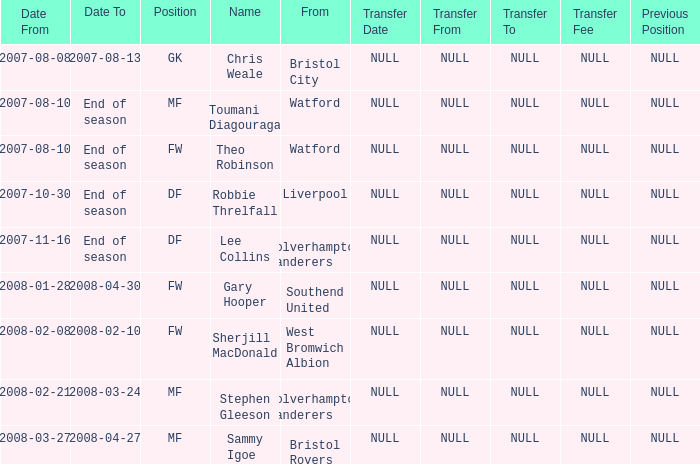For theo robinson, who was part of the team until the season finale, what was his date from? 2007-08-10. 